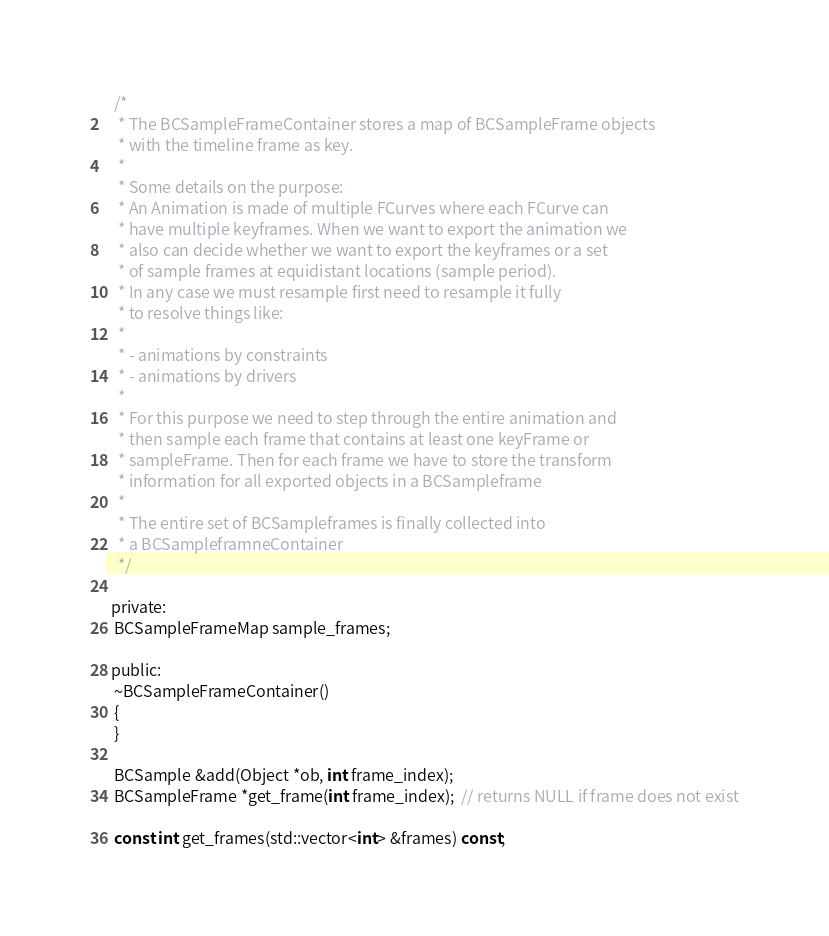Convert code to text. <code><loc_0><loc_0><loc_500><loc_500><_C_>  /*
   * The BCSampleFrameContainer stores a map of BCSampleFrame objects
   * with the timeline frame as key.
   *
   * Some details on the purpose:
   * An Animation is made of multiple FCurves where each FCurve can
   * have multiple keyframes. When we want to export the animation we
   * also can decide whether we want to export the keyframes or a set
   * of sample frames at equidistant locations (sample period).
   * In any case we must resample first need to resample it fully
   * to resolve things like:
   *
   * - animations by constraints
   * - animations by drivers
   *
   * For this purpose we need to step through the entire animation and
   * then sample each frame that contains at least one keyFrame or
   * sampleFrame. Then for each frame we have to store the transform
   * information for all exported objects in a BCSampleframe
   *
   * The entire set of BCSampleframes is finally collected into
   * a BCSampleframneContainer
   */

 private:
  BCSampleFrameMap sample_frames;

 public:
  ~BCSampleFrameContainer()
  {
  }

  BCSample &add(Object *ob, int frame_index);
  BCSampleFrame *get_frame(int frame_index);  // returns NULL if frame does not exist

  const int get_frames(std::vector<int> &frames) const;</code> 